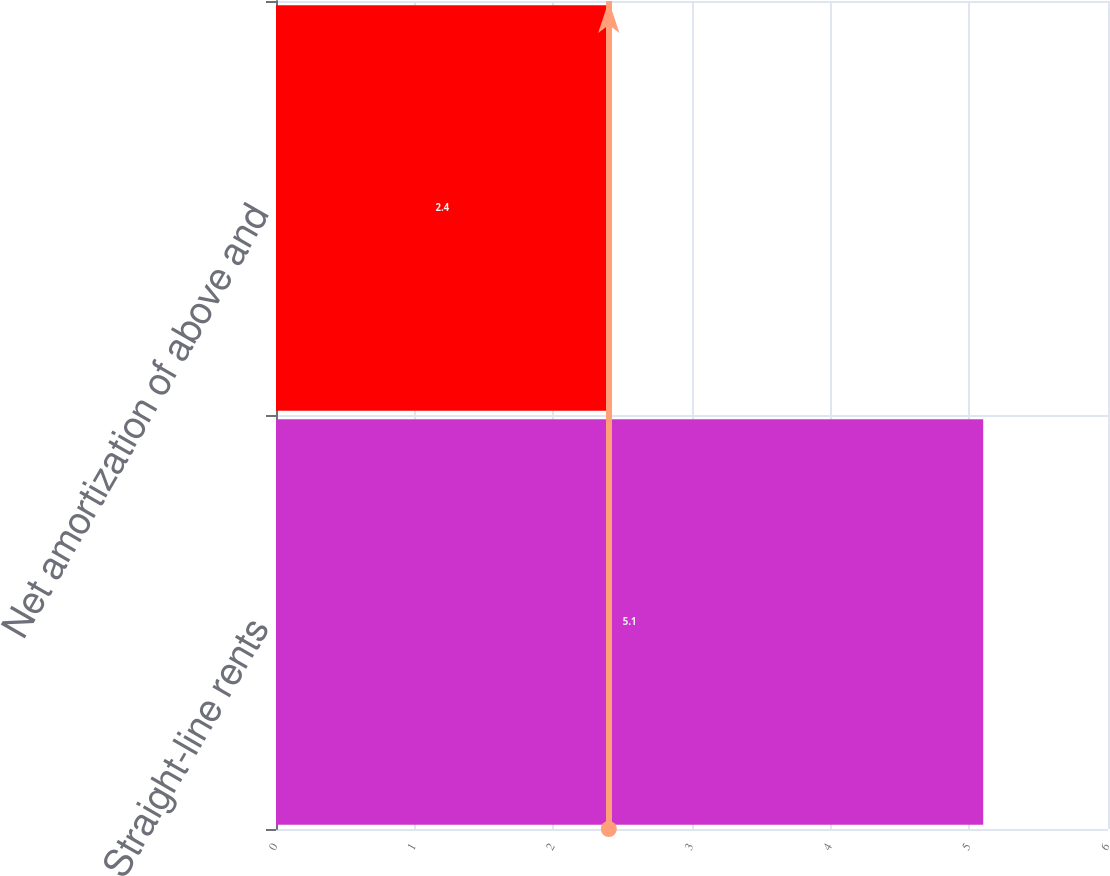Convert chart. <chart><loc_0><loc_0><loc_500><loc_500><bar_chart><fcel>Straight-line rents<fcel>Net amortization of above and<nl><fcel>5.1<fcel>2.4<nl></chart> 